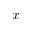<formula> <loc_0><loc_0><loc_500><loc_500>x</formula> 